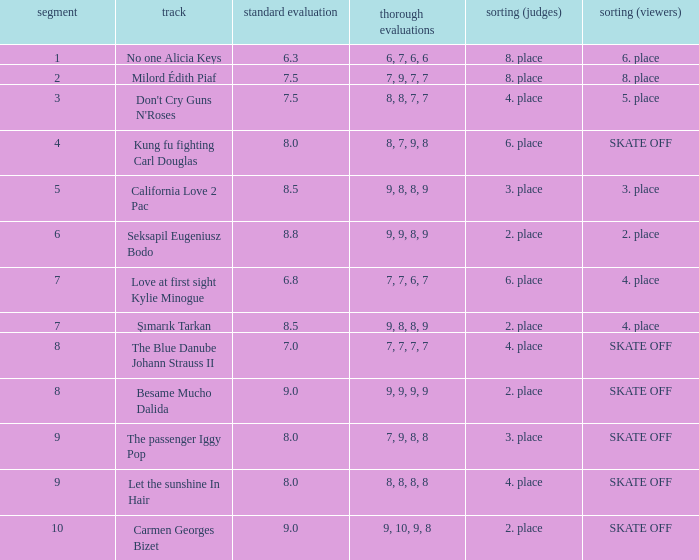Help me parse the entirety of this table. {'header': ['segment', 'track', 'standard evaluation', 'thorough evaluations', 'sorting (judges)', 'sorting (viewers)'], 'rows': [['1', 'No one Alicia Keys', '6.3', '6, 7, 6, 6', '8. place', '6. place'], ['2', 'Milord Édith Piaf', '7.5', '7, 9, 7, 7', '8. place', '8. place'], ['3', "Don't Cry Guns N'Roses", '7.5', '8, 8, 7, 7', '4. place', '5. place'], ['4', 'Kung fu fighting Carl Douglas', '8.0', '8, 7, 9, 8', '6. place', 'SKATE OFF'], ['5', 'California Love 2 Pac', '8.5', '9, 8, 8, 9', '3. place', '3. place'], ['6', 'Seksapil Eugeniusz Bodo', '8.8', '9, 9, 8, 9', '2. place', '2. place'], ['7', 'Love at first sight Kylie Minogue', '6.8', '7, 7, 6, 7', '6. place', '4. place'], ['7', 'Şımarık Tarkan', '8.5', '9, 8, 8, 9', '2. place', '4. place'], ['8', 'The Blue Danube Johann Strauss II', '7.0', '7, 7, 7, 7', '4. place', 'SKATE OFF'], ['8', 'Besame Mucho Dalida', '9.0', '9, 9, 9, 9', '2. place', 'SKATE OFF'], ['9', 'The passenger Iggy Pop', '8.0', '7, 9, 8, 8', '3. place', 'SKATE OFF'], ['9', 'Let the sunshine In Hair', '8.0', '8, 8, 8, 8', '4. place', 'SKATE OFF'], ['10', 'Carmen Georges Bizet', '9.0', '9, 10, 9, 8', '2. place', 'SKATE OFF']]} Name the classification for 9, 9, 8, 9 2. place. 